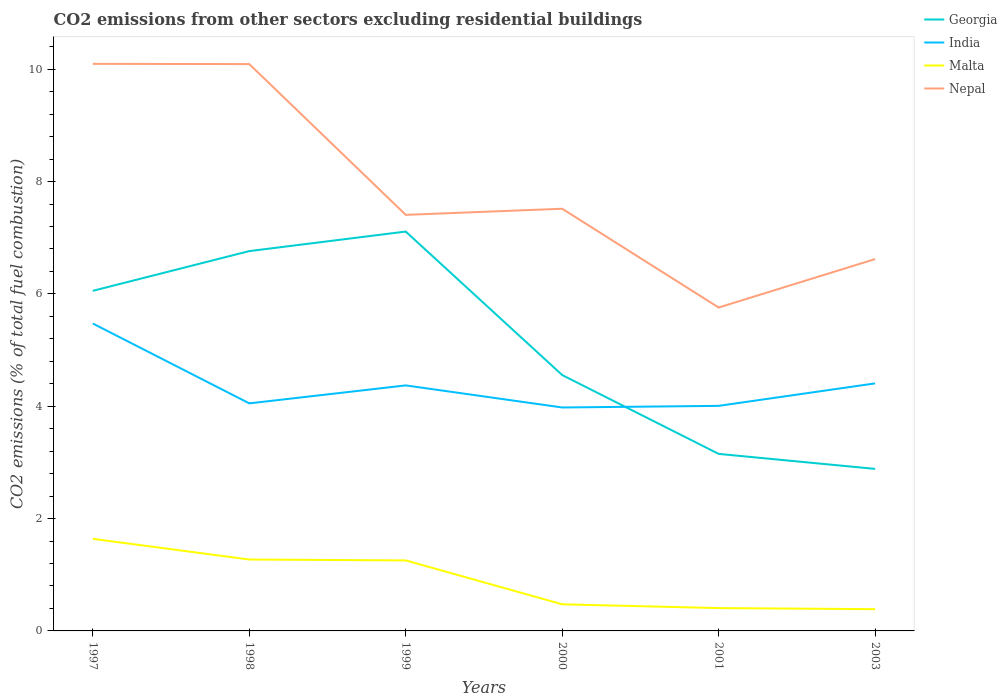How many different coloured lines are there?
Make the answer very short. 4. Does the line corresponding to Georgia intersect with the line corresponding to Malta?
Your response must be concise. No. Is the number of lines equal to the number of legend labels?
Your answer should be very brief. Yes. Across all years, what is the maximum total CO2 emitted in Georgia?
Keep it short and to the point. 2.88. What is the total total CO2 emitted in India in the graph?
Offer a terse response. 1.07. What is the difference between the highest and the second highest total CO2 emitted in India?
Keep it short and to the point. 1.49. What is the difference between the highest and the lowest total CO2 emitted in Nepal?
Ensure brevity in your answer.  2. Is the total CO2 emitted in India strictly greater than the total CO2 emitted in Georgia over the years?
Your answer should be compact. No. How many years are there in the graph?
Offer a terse response. 6. Are the values on the major ticks of Y-axis written in scientific E-notation?
Your answer should be compact. No. Does the graph contain grids?
Your answer should be compact. No. How many legend labels are there?
Ensure brevity in your answer.  4. How are the legend labels stacked?
Offer a terse response. Vertical. What is the title of the graph?
Provide a short and direct response. CO2 emissions from other sectors excluding residential buildings. Does "North America" appear as one of the legend labels in the graph?
Offer a very short reply. No. What is the label or title of the Y-axis?
Your answer should be very brief. CO2 emissions (% of total fuel combustion). What is the CO2 emissions (% of total fuel combustion) of Georgia in 1997?
Keep it short and to the point. 6.06. What is the CO2 emissions (% of total fuel combustion) in India in 1997?
Your answer should be very brief. 5.47. What is the CO2 emissions (% of total fuel combustion) of Malta in 1997?
Your answer should be compact. 1.64. What is the CO2 emissions (% of total fuel combustion) in Nepal in 1997?
Make the answer very short. 10.1. What is the CO2 emissions (% of total fuel combustion) in Georgia in 1998?
Give a very brief answer. 6.76. What is the CO2 emissions (% of total fuel combustion) of India in 1998?
Offer a very short reply. 4.05. What is the CO2 emissions (% of total fuel combustion) of Malta in 1998?
Provide a succinct answer. 1.27. What is the CO2 emissions (% of total fuel combustion) of Nepal in 1998?
Make the answer very short. 10.09. What is the CO2 emissions (% of total fuel combustion) in Georgia in 1999?
Provide a succinct answer. 7.11. What is the CO2 emissions (% of total fuel combustion) of India in 1999?
Provide a short and direct response. 4.37. What is the CO2 emissions (% of total fuel combustion) of Malta in 1999?
Your answer should be very brief. 1.26. What is the CO2 emissions (% of total fuel combustion) of Nepal in 1999?
Your response must be concise. 7.41. What is the CO2 emissions (% of total fuel combustion) of Georgia in 2000?
Keep it short and to the point. 4.56. What is the CO2 emissions (% of total fuel combustion) of India in 2000?
Offer a very short reply. 3.98. What is the CO2 emissions (% of total fuel combustion) of Malta in 2000?
Offer a terse response. 0.47. What is the CO2 emissions (% of total fuel combustion) of Nepal in 2000?
Offer a terse response. 7.52. What is the CO2 emissions (% of total fuel combustion) of Georgia in 2001?
Provide a short and direct response. 3.15. What is the CO2 emissions (% of total fuel combustion) of India in 2001?
Keep it short and to the point. 4.01. What is the CO2 emissions (% of total fuel combustion) in Malta in 2001?
Offer a terse response. 0.41. What is the CO2 emissions (% of total fuel combustion) in Nepal in 2001?
Offer a very short reply. 5.76. What is the CO2 emissions (% of total fuel combustion) of Georgia in 2003?
Your answer should be very brief. 2.88. What is the CO2 emissions (% of total fuel combustion) of India in 2003?
Give a very brief answer. 4.41. What is the CO2 emissions (% of total fuel combustion) in Malta in 2003?
Your response must be concise. 0.39. What is the CO2 emissions (% of total fuel combustion) in Nepal in 2003?
Your response must be concise. 6.62. Across all years, what is the maximum CO2 emissions (% of total fuel combustion) in Georgia?
Make the answer very short. 7.11. Across all years, what is the maximum CO2 emissions (% of total fuel combustion) of India?
Offer a terse response. 5.47. Across all years, what is the maximum CO2 emissions (% of total fuel combustion) of Malta?
Ensure brevity in your answer.  1.64. Across all years, what is the maximum CO2 emissions (% of total fuel combustion) in Nepal?
Provide a short and direct response. 10.1. Across all years, what is the minimum CO2 emissions (% of total fuel combustion) of Georgia?
Offer a terse response. 2.88. Across all years, what is the minimum CO2 emissions (% of total fuel combustion) of India?
Provide a short and direct response. 3.98. Across all years, what is the minimum CO2 emissions (% of total fuel combustion) in Malta?
Your response must be concise. 0.39. Across all years, what is the minimum CO2 emissions (% of total fuel combustion) in Nepal?
Give a very brief answer. 5.76. What is the total CO2 emissions (% of total fuel combustion) of Georgia in the graph?
Provide a succinct answer. 30.52. What is the total CO2 emissions (% of total fuel combustion) in India in the graph?
Make the answer very short. 26.29. What is the total CO2 emissions (% of total fuel combustion) in Malta in the graph?
Your response must be concise. 5.43. What is the total CO2 emissions (% of total fuel combustion) of Nepal in the graph?
Keep it short and to the point. 47.49. What is the difference between the CO2 emissions (% of total fuel combustion) in Georgia in 1997 and that in 1998?
Your response must be concise. -0.71. What is the difference between the CO2 emissions (% of total fuel combustion) in India in 1997 and that in 1998?
Your response must be concise. 1.42. What is the difference between the CO2 emissions (% of total fuel combustion) in Malta in 1997 and that in 1998?
Keep it short and to the point. 0.37. What is the difference between the CO2 emissions (% of total fuel combustion) of Nepal in 1997 and that in 1998?
Ensure brevity in your answer.  0. What is the difference between the CO2 emissions (% of total fuel combustion) in Georgia in 1997 and that in 1999?
Offer a very short reply. -1.05. What is the difference between the CO2 emissions (% of total fuel combustion) of India in 1997 and that in 1999?
Your answer should be compact. 1.1. What is the difference between the CO2 emissions (% of total fuel combustion) of Malta in 1997 and that in 1999?
Your answer should be very brief. 0.38. What is the difference between the CO2 emissions (% of total fuel combustion) in Nepal in 1997 and that in 1999?
Your response must be concise. 2.69. What is the difference between the CO2 emissions (% of total fuel combustion) in Georgia in 1997 and that in 2000?
Provide a short and direct response. 1.5. What is the difference between the CO2 emissions (% of total fuel combustion) in India in 1997 and that in 2000?
Provide a short and direct response. 1.49. What is the difference between the CO2 emissions (% of total fuel combustion) of Malta in 1997 and that in 2000?
Offer a very short reply. 1.17. What is the difference between the CO2 emissions (% of total fuel combustion) of Nepal in 1997 and that in 2000?
Keep it short and to the point. 2.58. What is the difference between the CO2 emissions (% of total fuel combustion) in Georgia in 1997 and that in 2001?
Your answer should be compact. 2.9. What is the difference between the CO2 emissions (% of total fuel combustion) in India in 1997 and that in 2001?
Keep it short and to the point. 1.47. What is the difference between the CO2 emissions (% of total fuel combustion) of Malta in 1997 and that in 2001?
Your response must be concise. 1.23. What is the difference between the CO2 emissions (% of total fuel combustion) in Nepal in 1997 and that in 2001?
Ensure brevity in your answer.  4.34. What is the difference between the CO2 emissions (% of total fuel combustion) of Georgia in 1997 and that in 2003?
Your response must be concise. 3.17. What is the difference between the CO2 emissions (% of total fuel combustion) of India in 1997 and that in 2003?
Your answer should be very brief. 1.07. What is the difference between the CO2 emissions (% of total fuel combustion) of Malta in 1997 and that in 2003?
Ensure brevity in your answer.  1.25. What is the difference between the CO2 emissions (% of total fuel combustion) in Nepal in 1997 and that in 2003?
Make the answer very short. 3.48. What is the difference between the CO2 emissions (% of total fuel combustion) in Georgia in 1998 and that in 1999?
Your response must be concise. -0.35. What is the difference between the CO2 emissions (% of total fuel combustion) in India in 1998 and that in 1999?
Provide a short and direct response. -0.32. What is the difference between the CO2 emissions (% of total fuel combustion) in Malta in 1998 and that in 1999?
Keep it short and to the point. 0.02. What is the difference between the CO2 emissions (% of total fuel combustion) in Nepal in 1998 and that in 1999?
Offer a terse response. 2.68. What is the difference between the CO2 emissions (% of total fuel combustion) of Georgia in 1998 and that in 2000?
Provide a short and direct response. 2.21. What is the difference between the CO2 emissions (% of total fuel combustion) in India in 1998 and that in 2000?
Your response must be concise. 0.07. What is the difference between the CO2 emissions (% of total fuel combustion) of Malta in 1998 and that in 2000?
Your answer should be very brief. 0.8. What is the difference between the CO2 emissions (% of total fuel combustion) in Nepal in 1998 and that in 2000?
Give a very brief answer. 2.58. What is the difference between the CO2 emissions (% of total fuel combustion) in Georgia in 1998 and that in 2001?
Ensure brevity in your answer.  3.61. What is the difference between the CO2 emissions (% of total fuel combustion) in India in 1998 and that in 2001?
Keep it short and to the point. 0.04. What is the difference between the CO2 emissions (% of total fuel combustion) of Malta in 1998 and that in 2001?
Give a very brief answer. 0.86. What is the difference between the CO2 emissions (% of total fuel combustion) of Nepal in 1998 and that in 2001?
Ensure brevity in your answer.  4.33. What is the difference between the CO2 emissions (% of total fuel combustion) of Georgia in 1998 and that in 2003?
Your response must be concise. 3.88. What is the difference between the CO2 emissions (% of total fuel combustion) in India in 1998 and that in 2003?
Offer a very short reply. -0.36. What is the difference between the CO2 emissions (% of total fuel combustion) in Malta in 1998 and that in 2003?
Offer a very short reply. 0.88. What is the difference between the CO2 emissions (% of total fuel combustion) of Nepal in 1998 and that in 2003?
Keep it short and to the point. 3.47. What is the difference between the CO2 emissions (% of total fuel combustion) in Georgia in 1999 and that in 2000?
Provide a succinct answer. 2.55. What is the difference between the CO2 emissions (% of total fuel combustion) in India in 1999 and that in 2000?
Make the answer very short. 0.39. What is the difference between the CO2 emissions (% of total fuel combustion) of Malta in 1999 and that in 2000?
Offer a terse response. 0.78. What is the difference between the CO2 emissions (% of total fuel combustion) of Nepal in 1999 and that in 2000?
Your answer should be very brief. -0.11. What is the difference between the CO2 emissions (% of total fuel combustion) in Georgia in 1999 and that in 2001?
Provide a succinct answer. 3.96. What is the difference between the CO2 emissions (% of total fuel combustion) in India in 1999 and that in 2001?
Your answer should be very brief. 0.36. What is the difference between the CO2 emissions (% of total fuel combustion) in Malta in 1999 and that in 2001?
Give a very brief answer. 0.85. What is the difference between the CO2 emissions (% of total fuel combustion) in Nepal in 1999 and that in 2001?
Your answer should be compact. 1.65. What is the difference between the CO2 emissions (% of total fuel combustion) of Georgia in 1999 and that in 2003?
Give a very brief answer. 4.23. What is the difference between the CO2 emissions (% of total fuel combustion) of India in 1999 and that in 2003?
Provide a short and direct response. -0.04. What is the difference between the CO2 emissions (% of total fuel combustion) of Malta in 1999 and that in 2003?
Offer a very short reply. 0.87. What is the difference between the CO2 emissions (% of total fuel combustion) of Nepal in 1999 and that in 2003?
Keep it short and to the point. 0.79. What is the difference between the CO2 emissions (% of total fuel combustion) of Georgia in 2000 and that in 2001?
Offer a very short reply. 1.4. What is the difference between the CO2 emissions (% of total fuel combustion) of India in 2000 and that in 2001?
Ensure brevity in your answer.  -0.03. What is the difference between the CO2 emissions (% of total fuel combustion) of Malta in 2000 and that in 2001?
Offer a terse response. 0.07. What is the difference between the CO2 emissions (% of total fuel combustion) of Nepal in 2000 and that in 2001?
Your answer should be compact. 1.76. What is the difference between the CO2 emissions (% of total fuel combustion) of Georgia in 2000 and that in 2003?
Offer a very short reply. 1.67. What is the difference between the CO2 emissions (% of total fuel combustion) in India in 2000 and that in 2003?
Provide a succinct answer. -0.43. What is the difference between the CO2 emissions (% of total fuel combustion) in Malta in 2000 and that in 2003?
Offer a very short reply. 0.09. What is the difference between the CO2 emissions (% of total fuel combustion) of Nepal in 2000 and that in 2003?
Keep it short and to the point. 0.9. What is the difference between the CO2 emissions (% of total fuel combustion) of Georgia in 2001 and that in 2003?
Offer a terse response. 0.27. What is the difference between the CO2 emissions (% of total fuel combustion) in India in 2001 and that in 2003?
Ensure brevity in your answer.  -0.4. What is the difference between the CO2 emissions (% of total fuel combustion) in Malta in 2001 and that in 2003?
Make the answer very short. 0.02. What is the difference between the CO2 emissions (% of total fuel combustion) in Nepal in 2001 and that in 2003?
Provide a succinct answer. -0.86. What is the difference between the CO2 emissions (% of total fuel combustion) of Georgia in 1997 and the CO2 emissions (% of total fuel combustion) of India in 1998?
Your response must be concise. 2. What is the difference between the CO2 emissions (% of total fuel combustion) of Georgia in 1997 and the CO2 emissions (% of total fuel combustion) of Malta in 1998?
Ensure brevity in your answer.  4.78. What is the difference between the CO2 emissions (% of total fuel combustion) in Georgia in 1997 and the CO2 emissions (% of total fuel combustion) in Nepal in 1998?
Ensure brevity in your answer.  -4.04. What is the difference between the CO2 emissions (% of total fuel combustion) in India in 1997 and the CO2 emissions (% of total fuel combustion) in Malta in 1998?
Your response must be concise. 4.2. What is the difference between the CO2 emissions (% of total fuel combustion) of India in 1997 and the CO2 emissions (% of total fuel combustion) of Nepal in 1998?
Keep it short and to the point. -4.62. What is the difference between the CO2 emissions (% of total fuel combustion) in Malta in 1997 and the CO2 emissions (% of total fuel combustion) in Nepal in 1998?
Provide a succinct answer. -8.45. What is the difference between the CO2 emissions (% of total fuel combustion) in Georgia in 1997 and the CO2 emissions (% of total fuel combustion) in India in 1999?
Give a very brief answer. 1.68. What is the difference between the CO2 emissions (% of total fuel combustion) of Georgia in 1997 and the CO2 emissions (% of total fuel combustion) of Malta in 1999?
Keep it short and to the point. 4.8. What is the difference between the CO2 emissions (% of total fuel combustion) in Georgia in 1997 and the CO2 emissions (% of total fuel combustion) in Nepal in 1999?
Give a very brief answer. -1.35. What is the difference between the CO2 emissions (% of total fuel combustion) in India in 1997 and the CO2 emissions (% of total fuel combustion) in Malta in 1999?
Your answer should be very brief. 4.22. What is the difference between the CO2 emissions (% of total fuel combustion) in India in 1997 and the CO2 emissions (% of total fuel combustion) in Nepal in 1999?
Provide a succinct answer. -1.93. What is the difference between the CO2 emissions (% of total fuel combustion) in Malta in 1997 and the CO2 emissions (% of total fuel combustion) in Nepal in 1999?
Ensure brevity in your answer.  -5.77. What is the difference between the CO2 emissions (% of total fuel combustion) of Georgia in 1997 and the CO2 emissions (% of total fuel combustion) of India in 2000?
Make the answer very short. 2.08. What is the difference between the CO2 emissions (% of total fuel combustion) of Georgia in 1997 and the CO2 emissions (% of total fuel combustion) of Malta in 2000?
Keep it short and to the point. 5.58. What is the difference between the CO2 emissions (% of total fuel combustion) in Georgia in 1997 and the CO2 emissions (% of total fuel combustion) in Nepal in 2000?
Your answer should be very brief. -1.46. What is the difference between the CO2 emissions (% of total fuel combustion) of India in 1997 and the CO2 emissions (% of total fuel combustion) of Malta in 2000?
Your response must be concise. 5. What is the difference between the CO2 emissions (% of total fuel combustion) of India in 1997 and the CO2 emissions (% of total fuel combustion) of Nepal in 2000?
Offer a terse response. -2.04. What is the difference between the CO2 emissions (% of total fuel combustion) in Malta in 1997 and the CO2 emissions (% of total fuel combustion) in Nepal in 2000?
Make the answer very short. -5.88. What is the difference between the CO2 emissions (% of total fuel combustion) in Georgia in 1997 and the CO2 emissions (% of total fuel combustion) in India in 2001?
Your answer should be compact. 2.05. What is the difference between the CO2 emissions (% of total fuel combustion) in Georgia in 1997 and the CO2 emissions (% of total fuel combustion) in Malta in 2001?
Offer a terse response. 5.65. What is the difference between the CO2 emissions (% of total fuel combustion) of Georgia in 1997 and the CO2 emissions (% of total fuel combustion) of Nepal in 2001?
Ensure brevity in your answer.  0.3. What is the difference between the CO2 emissions (% of total fuel combustion) in India in 1997 and the CO2 emissions (% of total fuel combustion) in Malta in 2001?
Offer a very short reply. 5.07. What is the difference between the CO2 emissions (% of total fuel combustion) of India in 1997 and the CO2 emissions (% of total fuel combustion) of Nepal in 2001?
Ensure brevity in your answer.  -0.28. What is the difference between the CO2 emissions (% of total fuel combustion) in Malta in 1997 and the CO2 emissions (% of total fuel combustion) in Nepal in 2001?
Keep it short and to the point. -4.12. What is the difference between the CO2 emissions (% of total fuel combustion) of Georgia in 1997 and the CO2 emissions (% of total fuel combustion) of India in 2003?
Give a very brief answer. 1.65. What is the difference between the CO2 emissions (% of total fuel combustion) in Georgia in 1997 and the CO2 emissions (% of total fuel combustion) in Malta in 2003?
Give a very brief answer. 5.67. What is the difference between the CO2 emissions (% of total fuel combustion) in Georgia in 1997 and the CO2 emissions (% of total fuel combustion) in Nepal in 2003?
Offer a very short reply. -0.57. What is the difference between the CO2 emissions (% of total fuel combustion) in India in 1997 and the CO2 emissions (% of total fuel combustion) in Malta in 2003?
Keep it short and to the point. 5.09. What is the difference between the CO2 emissions (% of total fuel combustion) in India in 1997 and the CO2 emissions (% of total fuel combustion) in Nepal in 2003?
Your answer should be very brief. -1.15. What is the difference between the CO2 emissions (% of total fuel combustion) of Malta in 1997 and the CO2 emissions (% of total fuel combustion) of Nepal in 2003?
Your answer should be very brief. -4.98. What is the difference between the CO2 emissions (% of total fuel combustion) of Georgia in 1998 and the CO2 emissions (% of total fuel combustion) of India in 1999?
Offer a very short reply. 2.39. What is the difference between the CO2 emissions (% of total fuel combustion) in Georgia in 1998 and the CO2 emissions (% of total fuel combustion) in Malta in 1999?
Your response must be concise. 5.51. What is the difference between the CO2 emissions (% of total fuel combustion) of Georgia in 1998 and the CO2 emissions (% of total fuel combustion) of Nepal in 1999?
Make the answer very short. -0.65. What is the difference between the CO2 emissions (% of total fuel combustion) of India in 1998 and the CO2 emissions (% of total fuel combustion) of Malta in 1999?
Offer a very short reply. 2.8. What is the difference between the CO2 emissions (% of total fuel combustion) in India in 1998 and the CO2 emissions (% of total fuel combustion) in Nepal in 1999?
Provide a succinct answer. -3.36. What is the difference between the CO2 emissions (% of total fuel combustion) of Malta in 1998 and the CO2 emissions (% of total fuel combustion) of Nepal in 1999?
Give a very brief answer. -6.14. What is the difference between the CO2 emissions (% of total fuel combustion) of Georgia in 1998 and the CO2 emissions (% of total fuel combustion) of India in 2000?
Provide a short and direct response. 2.78. What is the difference between the CO2 emissions (% of total fuel combustion) of Georgia in 1998 and the CO2 emissions (% of total fuel combustion) of Malta in 2000?
Your response must be concise. 6.29. What is the difference between the CO2 emissions (% of total fuel combustion) of Georgia in 1998 and the CO2 emissions (% of total fuel combustion) of Nepal in 2000?
Offer a very short reply. -0.75. What is the difference between the CO2 emissions (% of total fuel combustion) of India in 1998 and the CO2 emissions (% of total fuel combustion) of Malta in 2000?
Make the answer very short. 3.58. What is the difference between the CO2 emissions (% of total fuel combustion) in India in 1998 and the CO2 emissions (% of total fuel combustion) in Nepal in 2000?
Make the answer very short. -3.46. What is the difference between the CO2 emissions (% of total fuel combustion) in Malta in 1998 and the CO2 emissions (% of total fuel combustion) in Nepal in 2000?
Give a very brief answer. -6.25. What is the difference between the CO2 emissions (% of total fuel combustion) in Georgia in 1998 and the CO2 emissions (% of total fuel combustion) in India in 2001?
Make the answer very short. 2.76. What is the difference between the CO2 emissions (% of total fuel combustion) of Georgia in 1998 and the CO2 emissions (% of total fuel combustion) of Malta in 2001?
Provide a short and direct response. 6.36. What is the difference between the CO2 emissions (% of total fuel combustion) in Georgia in 1998 and the CO2 emissions (% of total fuel combustion) in Nepal in 2001?
Keep it short and to the point. 1. What is the difference between the CO2 emissions (% of total fuel combustion) in India in 1998 and the CO2 emissions (% of total fuel combustion) in Malta in 2001?
Your answer should be compact. 3.64. What is the difference between the CO2 emissions (% of total fuel combustion) in India in 1998 and the CO2 emissions (% of total fuel combustion) in Nepal in 2001?
Make the answer very short. -1.71. What is the difference between the CO2 emissions (% of total fuel combustion) of Malta in 1998 and the CO2 emissions (% of total fuel combustion) of Nepal in 2001?
Give a very brief answer. -4.49. What is the difference between the CO2 emissions (% of total fuel combustion) in Georgia in 1998 and the CO2 emissions (% of total fuel combustion) in India in 2003?
Provide a succinct answer. 2.36. What is the difference between the CO2 emissions (% of total fuel combustion) of Georgia in 1998 and the CO2 emissions (% of total fuel combustion) of Malta in 2003?
Keep it short and to the point. 6.37. What is the difference between the CO2 emissions (% of total fuel combustion) in Georgia in 1998 and the CO2 emissions (% of total fuel combustion) in Nepal in 2003?
Keep it short and to the point. 0.14. What is the difference between the CO2 emissions (% of total fuel combustion) of India in 1998 and the CO2 emissions (% of total fuel combustion) of Malta in 2003?
Keep it short and to the point. 3.66. What is the difference between the CO2 emissions (% of total fuel combustion) in India in 1998 and the CO2 emissions (% of total fuel combustion) in Nepal in 2003?
Ensure brevity in your answer.  -2.57. What is the difference between the CO2 emissions (% of total fuel combustion) in Malta in 1998 and the CO2 emissions (% of total fuel combustion) in Nepal in 2003?
Offer a very short reply. -5.35. What is the difference between the CO2 emissions (% of total fuel combustion) in Georgia in 1999 and the CO2 emissions (% of total fuel combustion) in India in 2000?
Your response must be concise. 3.13. What is the difference between the CO2 emissions (% of total fuel combustion) of Georgia in 1999 and the CO2 emissions (% of total fuel combustion) of Malta in 2000?
Keep it short and to the point. 6.64. What is the difference between the CO2 emissions (% of total fuel combustion) of Georgia in 1999 and the CO2 emissions (% of total fuel combustion) of Nepal in 2000?
Your response must be concise. -0.41. What is the difference between the CO2 emissions (% of total fuel combustion) in India in 1999 and the CO2 emissions (% of total fuel combustion) in Malta in 2000?
Keep it short and to the point. 3.9. What is the difference between the CO2 emissions (% of total fuel combustion) in India in 1999 and the CO2 emissions (% of total fuel combustion) in Nepal in 2000?
Your answer should be compact. -3.15. What is the difference between the CO2 emissions (% of total fuel combustion) of Malta in 1999 and the CO2 emissions (% of total fuel combustion) of Nepal in 2000?
Your answer should be very brief. -6.26. What is the difference between the CO2 emissions (% of total fuel combustion) of Georgia in 1999 and the CO2 emissions (% of total fuel combustion) of India in 2001?
Your response must be concise. 3.1. What is the difference between the CO2 emissions (% of total fuel combustion) of Georgia in 1999 and the CO2 emissions (% of total fuel combustion) of Malta in 2001?
Provide a short and direct response. 6.7. What is the difference between the CO2 emissions (% of total fuel combustion) in Georgia in 1999 and the CO2 emissions (% of total fuel combustion) in Nepal in 2001?
Provide a short and direct response. 1.35. What is the difference between the CO2 emissions (% of total fuel combustion) in India in 1999 and the CO2 emissions (% of total fuel combustion) in Malta in 2001?
Your answer should be compact. 3.96. What is the difference between the CO2 emissions (% of total fuel combustion) in India in 1999 and the CO2 emissions (% of total fuel combustion) in Nepal in 2001?
Make the answer very short. -1.39. What is the difference between the CO2 emissions (% of total fuel combustion) in Malta in 1999 and the CO2 emissions (% of total fuel combustion) in Nepal in 2001?
Provide a short and direct response. -4.5. What is the difference between the CO2 emissions (% of total fuel combustion) in Georgia in 1999 and the CO2 emissions (% of total fuel combustion) in India in 2003?
Your answer should be very brief. 2.7. What is the difference between the CO2 emissions (% of total fuel combustion) in Georgia in 1999 and the CO2 emissions (% of total fuel combustion) in Malta in 2003?
Make the answer very short. 6.72. What is the difference between the CO2 emissions (% of total fuel combustion) in Georgia in 1999 and the CO2 emissions (% of total fuel combustion) in Nepal in 2003?
Your response must be concise. 0.49. What is the difference between the CO2 emissions (% of total fuel combustion) in India in 1999 and the CO2 emissions (% of total fuel combustion) in Malta in 2003?
Your answer should be very brief. 3.98. What is the difference between the CO2 emissions (% of total fuel combustion) of India in 1999 and the CO2 emissions (% of total fuel combustion) of Nepal in 2003?
Your answer should be very brief. -2.25. What is the difference between the CO2 emissions (% of total fuel combustion) of Malta in 1999 and the CO2 emissions (% of total fuel combustion) of Nepal in 2003?
Offer a very short reply. -5.37. What is the difference between the CO2 emissions (% of total fuel combustion) in Georgia in 2000 and the CO2 emissions (% of total fuel combustion) in India in 2001?
Keep it short and to the point. 0.55. What is the difference between the CO2 emissions (% of total fuel combustion) of Georgia in 2000 and the CO2 emissions (% of total fuel combustion) of Malta in 2001?
Offer a very short reply. 4.15. What is the difference between the CO2 emissions (% of total fuel combustion) of Georgia in 2000 and the CO2 emissions (% of total fuel combustion) of Nepal in 2001?
Your answer should be compact. -1.2. What is the difference between the CO2 emissions (% of total fuel combustion) in India in 2000 and the CO2 emissions (% of total fuel combustion) in Malta in 2001?
Keep it short and to the point. 3.57. What is the difference between the CO2 emissions (% of total fuel combustion) in India in 2000 and the CO2 emissions (% of total fuel combustion) in Nepal in 2001?
Keep it short and to the point. -1.78. What is the difference between the CO2 emissions (% of total fuel combustion) in Malta in 2000 and the CO2 emissions (% of total fuel combustion) in Nepal in 2001?
Your answer should be very brief. -5.28. What is the difference between the CO2 emissions (% of total fuel combustion) of Georgia in 2000 and the CO2 emissions (% of total fuel combustion) of India in 2003?
Ensure brevity in your answer.  0.15. What is the difference between the CO2 emissions (% of total fuel combustion) in Georgia in 2000 and the CO2 emissions (% of total fuel combustion) in Malta in 2003?
Your answer should be compact. 4.17. What is the difference between the CO2 emissions (% of total fuel combustion) in Georgia in 2000 and the CO2 emissions (% of total fuel combustion) in Nepal in 2003?
Offer a very short reply. -2.06. What is the difference between the CO2 emissions (% of total fuel combustion) in India in 2000 and the CO2 emissions (% of total fuel combustion) in Malta in 2003?
Give a very brief answer. 3.59. What is the difference between the CO2 emissions (% of total fuel combustion) in India in 2000 and the CO2 emissions (% of total fuel combustion) in Nepal in 2003?
Keep it short and to the point. -2.64. What is the difference between the CO2 emissions (% of total fuel combustion) of Malta in 2000 and the CO2 emissions (% of total fuel combustion) of Nepal in 2003?
Keep it short and to the point. -6.15. What is the difference between the CO2 emissions (% of total fuel combustion) of Georgia in 2001 and the CO2 emissions (% of total fuel combustion) of India in 2003?
Your response must be concise. -1.26. What is the difference between the CO2 emissions (% of total fuel combustion) in Georgia in 2001 and the CO2 emissions (% of total fuel combustion) in Malta in 2003?
Keep it short and to the point. 2.76. What is the difference between the CO2 emissions (% of total fuel combustion) in Georgia in 2001 and the CO2 emissions (% of total fuel combustion) in Nepal in 2003?
Provide a succinct answer. -3.47. What is the difference between the CO2 emissions (% of total fuel combustion) of India in 2001 and the CO2 emissions (% of total fuel combustion) of Malta in 2003?
Provide a short and direct response. 3.62. What is the difference between the CO2 emissions (% of total fuel combustion) of India in 2001 and the CO2 emissions (% of total fuel combustion) of Nepal in 2003?
Make the answer very short. -2.61. What is the difference between the CO2 emissions (% of total fuel combustion) of Malta in 2001 and the CO2 emissions (% of total fuel combustion) of Nepal in 2003?
Ensure brevity in your answer.  -6.21. What is the average CO2 emissions (% of total fuel combustion) in Georgia per year?
Give a very brief answer. 5.09. What is the average CO2 emissions (% of total fuel combustion) in India per year?
Offer a terse response. 4.38. What is the average CO2 emissions (% of total fuel combustion) of Malta per year?
Provide a short and direct response. 0.91. What is the average CO2 emissions (% of total fuel combustion) in Nepal per year?
Offer a very short reply. 7.91. In the year 1997, what is the difference between the CO2 emissions (% of total fuel combustion) of Georgia and CO2 emissions (% of total fuel combustion) of India?
Offer a very short reply. 0.58. In the year 1997, what is the difference between the CO2 emissions (% of total fuel combustion) of Georgia and CO2 emissions (% of total fuel combustion) of Malta?
Offer a terse response. 4.42. In the year 1997, what is the difference between the CO2 emissions (% of total fuel combustion) in Georgia and CO2 emissions (% of total fuel combustion) in Nepal?
Your response must be concise. -4.04. In the year 1997, what is the difference between the CO2 emissions (% of total fuel combustion) in India and CO2 emissions (% of total fuel combustion) in Malta?
Provide a short and direct response. 3.83. In the year 1997, what is the difference between the CO2 emissions (% of total fuel combustion) in India and CO2 emissions (% of total fuel combustion) in Nepal?
Provide a succinct answer. -4.62. In the year 1997, what is the difference between the CO2 emissions (% of total fuel combustion) of Malta and CO2 emissions (% of total fuel combustion) of Nepal?
Offer a terse response. -8.46. In the year 1998, what is the difference between the CO2 emissions (% of total fuel combustion) in Georgia and CO2 emissions (% of total fuel combustion) in India?
Your answer should be very brief. 2.71. In the year 1998, what is the difference between the CO2 emissions (% of total fuel combustion) of Georgia and CO2 emissions (% of total fuel combustion) of Malta?
Your answer should be compact. 5.49. In the year 1998, what is the difference between the CO2 emissions (% of total fuel combustion) in Georgia and CO2 emissions (% of total fuel combustion) in Nepal?
Your answer should be very brief. -3.33. In the year 1998, what is the difference between the CO2 emissions (% of total fuel combustion) of India and CO2 emissions (% of total fuel combustion) of Malta?
Your answer should be very brief. 2.78. In the year 1998, what is the difference between the CO2 emissions (% of total fuel combustion) of India and CO2 emissions (% of total fuel combustion) of Nepal?
Make the answer very short. -6.04. In the year 1998, what is the difference between the CO2 emissions (% of total fuel combustion) of Malta and CO2 emissions (% of total fuel combustion) of Nepal?
Provide a succinct answer. -8.82. In the year 1999, what is the difference between the CO2 emissions (% of total fuel combustion) in Georgia and CO2 emissions (% of total fuel combustion) in India?
Offer a terse response. 2.74. In the year 1999, what is the difference between the CO2 emissions (% of total fuel combustion) in Georgia and CO2 emissions (% of total fuel combustion) in Malta?
Your response must be concise. 5.85. In the year 1999, what is the difference between the CO2 emissions (% of total fuel combustion) of Georgia and CO2 emissions (% of total fuel combustion) of Nepal?
Offer a terse response. -0.3. In the year 1999, what is the difference between the CO2 emissions (% of total fuel combustion) in India and CO2 emissions (% of total fuel combustion) in Malta?
Provide a short and direct response. 3.12. In the year 1999, what is the difference between the CO2 emissions (% of total fuel combustion) in India and CO2 emissions (% of total fuel combustion) in Nepal?
Give a very brief answer. -3.04. In the year 1999, what is the difference between the CO2 emissions (% of total fuel combustion) in Malta and CO2 emissions (% of total fuel combustion) in Nepal?
Offer a very short reply. -6.15. In the year 2000, what is the difference between the CO2 emissions (% of total fuel combustion) of Georgia and CO2 emissions (% of total fuel combustion) of India?
Your answer should be compact. 0.58. In the year 2000, what is the difference between the CO2 emissions (% of total fuel combustion) of Georgia and CO2 emissions (% of total fuel combustion) of Malta?
Your answer should be compact. 4.08. In the year 2000, what is the difference between the CO2 emissions (% of total fuel combustion) in Georgia and CO2 emissions (% of total fuel combustion) in Nepal?
Your answer should be compact. -2.96. In the year 2000, what is the difference between the CO2 emissions (% of total fuel combustion) of India and CO2 emissions (% of total fuel combustion) of Malta?
Offer a terse response. 3.5. In the year 2000, what is the difference between the CO2 emissions (% of total fuel combustion) of India and CO2 emissions (% of total fuel combustion) of Nepal?
Keep it short and to the point. -3.54. In the year 2000, what is the difference between the CO2 emissions (% of total fuel combustion) of Malta and CO2 emissions (% of total fuel combustion) of Nepal?
Provide a succinct answer. -7.04. In the year 2001, what is the difference between the CO2 emissions (% of total fuel combustion) in Georgia and CO2 emissions (% of total fuel combustion) in India?
Your response must be concise. -0.86. In the year 2001, what is the difference between the CO2 emissions (% of total fuel combustion) of Georgia and CO2 emissions (% of total fuel combustion) of Malta?
Make the answer very short. 2.75. In the year 2001, what is the difference between the CO2 emissions (% of total fuel combustion) in Georgia and CO2 emissions (% of total fuel combustion) in Nepal?
Your answer should be very brief. -2.61. In the year 2001, what is the difference between the CO2 emissions (% of total fuel combustion) in India and CO2 emissions (% of total fuel combustion) in Malta?
Your response must be concise. 3.6. In the year 2001, what is the difference between the CO2 emissions (% of total fuel combustion) of India and CO2 emissions (% of total fuel combustion) of Nepal?
Offer a very short reply. -1.75. In the year 2001, what is the difference between the CO2 emissions (% of total fuel combustion) of Malta and CO2 emissions (% of total fuel combustion) of Nepal?
Provide a short and direct response. -5.35. In the year 2003, what is the difference between the CO2 emissions (% of total fuel combustion) in Georgia and CO2 emissions (% of total fuel combustion) in India?
Give a very brief answer. -1.52. In the year 2003, what is the difference between the CO2 emissions (% of total fuel combustion) in Georgia and CO2 emissions (% of total fuel combustion) in Malta?
Your answer should be compact. 2.5. In the year 2003, what is the difference between the CO2 emissions (% of total fuel combustion) of Georgia and CO2 emissions (% of total fuel combustion) of Nepal?
Ensure brevity in your answer.  -3.74. In the year 2003, what is the difference between the CO2 emissions (% of total fuel combustion) in India and CO2 emissions (% of total fuel combustion) in Malta?
Ensure brevity in your answer.  4.02. In the year 2003, what is the difference between the CO2 emissions (% of total fuel combustion) of India and CO2 emissions (% of total fuel combustion) of Nepal?
Your answer should be very brief. -2.21. In the year 2003, what is the difference between the CO2 emissions (% of total fuel combustion) in Malta and CO2 emissions (% of total fuel combustion) in Nepal?
Offer a very short reply. -6.23. What is the ratio of the CO2 emissions (% of total fuel combustion) in Georgia in 1997 to that in 1998?
Provide a short and direct response. 0.9. What is the ratio of the CO2 emissions (% of total fuel combustion) of India in 1997 to that in 1998?
Offer a terse response. 1.35. What is the ratio of the CO2 emissions (% of total fuel combustion) of Malta in 1997 to that in 1998?
Provide a short and direct response. 1.29. What is the ratio of the CO2 emissions (% of total fuel combustion) in Nepal in 1997 to that in 1998?
Make the answer very short. 1. What is the ratio of the CO2 emissions (% of total fuel combustion) in Georgia in 1997 to that in 1999?
Provide a succinct answer. 0.85. What is the ratio of the CO2 emissions (% of total fuel combustion) of India in 1997 to that in 1999?
Keep it short and to the point. 1.25. What is the ratio of the CO2 emissions (% of total fuel combustion) of Malta in 1997 to that in 1999?
Keep it short and to the point. 1.31. What is the ratio of the CO2 emissions (% of total fuel combustion) of Nepal in 1997 to that in 1999?
Ensure brevity in your answer.  1.36. What is the ratio of the CO2 emissions (% of total fuel combustion) in Georgia in 1997 to that in 2000?
Offer a very short reply. 1.33. What is the ratio of the CO2 emissions (% of total fuel combustion) in India in 1997 to that in 2000?
Keep it short and to the point. 1.38. What is the ratio of the CO2 emissions (% of total fuel combustion) in Malta in 1997 to that in 2000?
Keep it short and to the point. 3.46. What is the ratio of the CO2 emissions (% of total fuel combustion) of Nepal in 1997 to that in 2000?
Your response must be concise. 1.34. What is the ratio of the CO2 emissions (% of total fuel combustion) in Georgia in 1997 to that in 2001?
Your answer should be compact. 1.92. What is the ratio of the CO2 emissions (% of total fuel combustion) in India in 1997 to that in 2001?
Make the answer very short. 1.37. What is the ratio of the CO2 emissions (% of total fuel combustion) of Malta in 1997 to that in 2001?
Your response must be concise. 4.03. What is the ratio of the CO2 emissions (% of total fuel combustion) in Nepal in 1997 to that in 2001?
Give a very brief answer. 1.75. What is the ratio of the CO2 emissions (% of total fuel combustion) in Georgia in 1997 to that in 2003?
Make the answer very short. 2.1. What is the ratio of the CO2 emissions (% of total fuel combustion) of India in 1997 to that in 2003?
Make the answer very short. 1.24. What is the ratio of the CO2 emissions (% of total fuel combustion) of Malta in 1997 to that in 2003?
Your answer should be very brief. 4.23. What is the ratio of the CO2 emissions (% of total fuel combustion) in Nepal in 1997 to that in 2003?
Make the answer very short. 1.53. What is the ratio of the CO2 emissions (% of total fuel combustion) in Georgia in 1998 to that in 1999?
Ensure brevity in your answer.  0.95. What is the ratio of the CO2 emissions (% of total fuel combustion) of India in 1998 to that in 1999?
Provide a succinct answer. 0.93. What is the ratio of the CO2 emissions (% of total fuel combustion) of Malta in 1998 to that in 1999?
Your response must be concise. 1.01. What is the ratio of the CO2 emissions (% of total fuel combustion) of Nepal in 1998 to that in 1999?
Keep it short and to the point. 1.36. What is the ratio of the CO2 emissions (% of total fuel combustion) of Georgia in 1998 to that in 2000?
Keep it short and to the point. 1.48. What is the ratio of the CO2 emissions (% of total fuel combustion) in India in 1998 to that in 2000?
Your response must be concise. 1.02. What is the ratio of the CO2 emissions (% of total fuel combustion) of Malta in 1998 to that in 2000?
Ensure brevity in your answer.  2.68. What is the ratio of the CO2 emissions (% of total fuel combustion) of Nepal in 1998 to that in 2000?
Keep it short and to the point. 1.34. What is the ratio of the CO2 emissions (% of total fuel combustion) of Georgia in 1998 to that in 2001?
Ensure brevity in your answer.  2.15. What is the ratio of the CO2 emissions (% of total fuel combustion) in India in 1998 to that in 2001?
Give a very brief answer. 1.01. What is the ratio of the CO2 emissions (% of total fuel combustion) of Malta in 1998 to that in 2001?
Provide a succinct answer. 3.13. What is the ratio of the CO2 emissions (% of total fuel combustion) of Nepal in 1998 to that in 2001?
Your answer should be very brief. 1.75. What is the ratio of the CO2 emissions (% of total fuel combustion) in Georgia in 1998 to that in 2003?
Make the answer very short. 2.34. What is the ratio of the CO2 emissions (% of total fuel combustion) of India in 1998 to that in 2003?
Ensure brevity in your answer.  0.92. What is the ratio of the CO2 emissions (% of total fuel combustion) of Malta in 1998 to that in 2003?
Keep it short and to the point. 3.28. What is the ratio of the CO2 emissions (% of total fuel combustion) of Nepal in 1998 to that in 2003?
Give a very brief answer. 1.52. What is the ratio of the CO2 emissions (% of total fuel combustion) in Georgia in 1999 to that in 2000?
Give a very brief answer. 1.56. What is the ratio of the CO2 emissions (% of total fuel combustion) in India in 1999 to that in 2000?
Offer a very short reply. 1.1. What is the ratio of the CO2 emissions (% of total fuel combustion) in Malta in 1999 to that in 2000?
Keep it short and to the point. 2.65. What is the ratio of the CO2 emissions (% of total fuel combustion) of Nepal in 1999 to that in 2000?
Ensure brevity in your answer.  0.99. What is the ratio of the CO2 emissions (% of total fuel combustion) in Georgia in 1999 to that in 2001?
Your answer should be compact. 2.26. What is the ratio of the CO2 emissions (% of total fuel combustion) in Malta in 1999 to that in 2001?
Your response must be concise. 3.09. What is the ratio of the CO2 emissions (% of total fuel combustion) of Nepal in 1999 to that in 2001?
Keep it short and to the point. 1.29. What is the ratio of the CO2 emissions (% of total fuel combustion) of Georgia in 1999 to that in 2003?
Keep it short and to the point. 2.46. What is the ratio of the CO2 emissions (% of total fuel combustion) in Malta in 1999 to that in 2003?
Provide a short and direct response. 3.24. What is the ratio of the CO2 emissions (% of total fuel combustion) of Nepal in 1999 to that in 2003?
Offer a terse response. 1.12. What is the ratio of the CO2 emissions (% of total fuel combustion) of Georgia in 2000 to that in 2001?
Offer a very short reply. 1.45. What is the ratio of the CO2 emissions (% of total fuel combustion) in Malta in 2000 to that in 2001?
Give a very brief answer. 1.17. What is the ratio of the CO2 emissions (% of total fuel combustion) in Nepal in 2000 to that in 2001?
Offer a terse response. 1.31. What is the ratio of the CO2 emissions (% of total fuel combustion) in Georgia in 2000 to that in 2003?
Your response must be concise. 1.58. What is the ratio of the CO2 emissions (% of total fuel combustion) of India in 2000 to that in 2003?
Your response must be concise. 0.9. What is the ratio of the CO2 emissions (% of total fuel combustion) of Malta in 2000 to that in 2003?
Your response must be concise. 1.22. What is the ratio of the CO2 emissions (% of total fuel combustion) in Nepal in 2000 to that in 2003?
Offer a very short reply. 1.14. What is the ratio of the CO2 emissions (% of total fuel combustion) of Georgia in 2001 to that in 2003?
Offer a very short reply. 1.09. What is the ratio of the CO2 emissions (% of total fuel combustion) in India in 2001 to that in 2003?
Provide a short and direct response. 0.91. What is the ratio of the CO2 emissions (% of total fuel combustion) in Malta in 2001 to that in 2003?
Keep it short and to the point. 1.05. What is the ratio of the CO2 emissions (% of total fuel combustion) of Nepal in 2001 to that in 2003?
Provide a succinct answer. 0.87. What is the difference between the highest and the second highest CO2 emissions (% of total fuel combustion) of Georgia?
Offer a terse response. 0.35. What is the difference between the highest and the second highest CO2 emissions (% of total fuel combustion) of India?
Keep it short and to the point. 1.07. What is the difference between the highest and the second highest CO2 emissions (% of total fuel combustion) of Malta?
Give a very brief answer. 0.37. What is the difference between the highest and the second highest CO2 emissions (% of total fuel combustion) in Nepal?
Keep it short and to the point. 0. What is the difference between the highest and the lowest CO2 emissions (% of total fuel combustion) in Georgia?
Give a very brief answer. 4.23. What is the difference between the highest and the lowest CO2 emissions (% of total fuel combustion) of India?
Make the answer very short. 1.49. What is the difference between the highest and the lowest CO2 emissions (% of total fuel combustion) of Malta?
Your response must be concise. 1.25. What is the difference between the highest and the lowest CO2 emissions (% of total fuel combustion) in Nepal?
Provide a short and direct response. 4.34. 